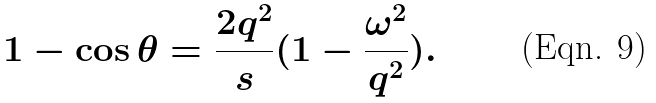Convert formula to latex. <formula><loc_0><loc_0><loc_500><loc_500>1 - \cos \theta = \frac { 2 q ^ { 2 } } { s } ( 1 - \frac { \omega ^ { 2 } } { q ^ { 2 } } ) .</formula> 